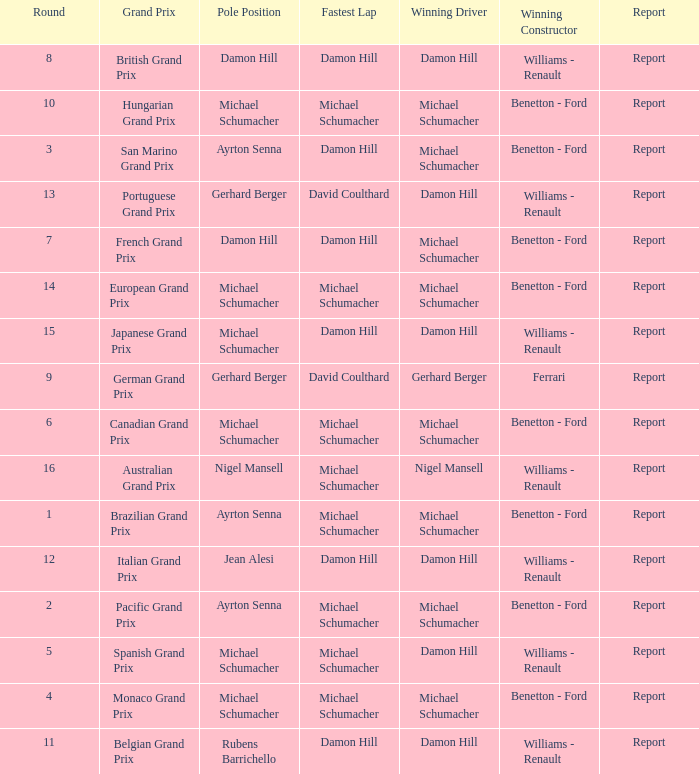Name the lowest round for when pole position and winning driver is michael schumacher 4.0. 